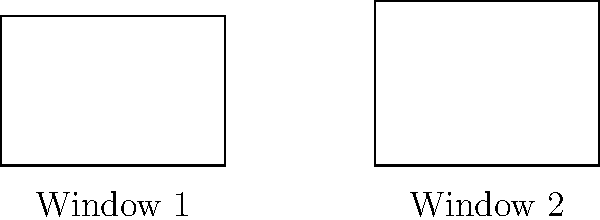As a homeowner in Ladysmith, WI, you're inspecting the windows of your property for uniformity. You notice that two windows appear slightly different. Given that Window 1 has dimensions of 3 feet by 2 feet, and Window 2 has the same width but appears taller, are these windows congruent? If not, what is the difference in their areas? Let's approach this step-by-step:

1) We know that Window 1 is 3 feet wide and 2 feet tall.
   Area of Window 1 = $3 \times 2 = 6$ square feet

2) Window 2 has the same width (3 feet) but appears taller.
   Let's say its height is $h$ feet.

3) For the windows to be congruent, they must have the same dimensions.
   However, we can see that the height is different.

4) To find the height of Window 2, we can use the information that it appears taller.
   From the image, we can estimate that it's about 10% taller.
   So, $h \approx 2.2$ feet

5) Area of Window 2 = $3 \times 2.2 = 6.6$ square feet

6) Difference in areas = Area of Window 2 - Area of Window 1
                       = $6.6 - 6 = 0.6$ square feet

Therefore, the windows are not congruent, and the difference in their areas is approximately 0.6 square feet.
Answer: Not congruent; 0.6 sq ft difference 